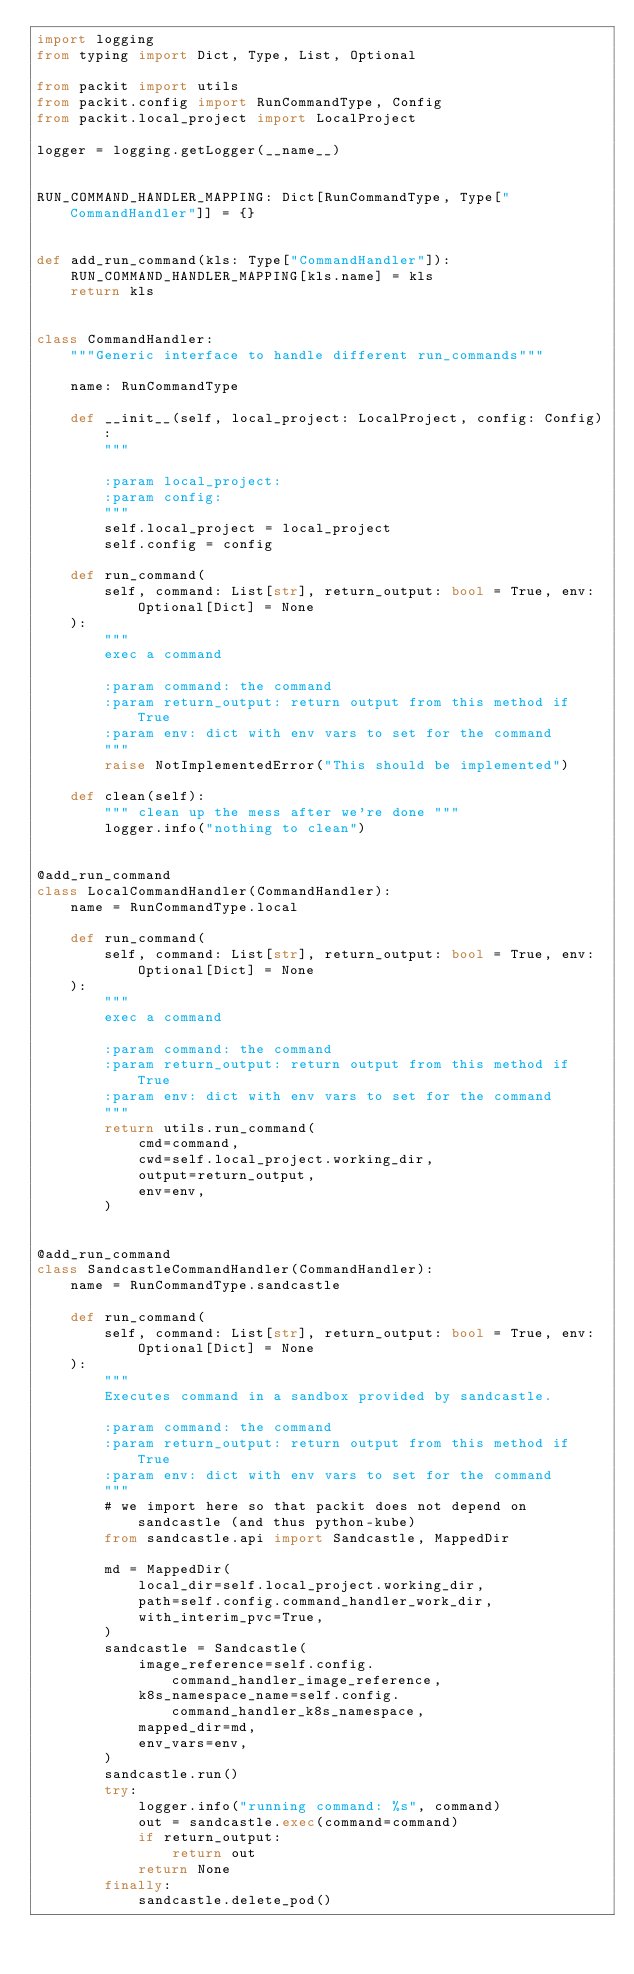<code> <loc_0><loc_0><loc_500><loc_500><_Python_>import logging
from typing import Dict, Type, List, Optional

from packit import utils
from packit.config import RunCommandType, Config
from packit.local_project import LocalProject

logger = logging.getLogger(__name__)


RUN_COMMAND_HANDLER_MAPPING: Dict[RunCommandType, Type["CommandHandler"]] = {}


def add_run_command(kls: Type["CommandHandler"]):
    RUN_COMMAND_HANDLER_MAPPING[kls.name] = kls
    return kls


class CommandHandler:
    """Generic interface to handle different run_commands"""

    name: RunCommandType

    def __init__(self, local_project: LocalProject, config: Config):
        """

        :param local_project:
        :param config:
        """
        self.local_project = local_project
        self.config = config

    def run_command(
        self, command: List[str], return_output: bool = True, env: Optional[Dict] = None
    ):
        """
        exec a command

        :param command: the command
        :param return_output: return output from this method if True
        :param env: dict with env vars to set for the command
        """
        raise NotImplementedError("This should be implemented")

    def clean(self):
        """ clean up the mess after we're done """
        logger.info("nothing to clean")


@add_run_command
class LocalCommandHandler(CommandHandler):
    name = RunCommandType.local

    def run_command(
        self, command: List[str], return_output: bool = True, env: Optional[Dict] = None
    ):
        """
        exec a command

        :param command: the command
        :param return_output: return output from this method if True
        :param env: dict with env vars to set for the command
        """
        return utils.run_command(
            cmd=command,
            cwd=self.local_project.working_dir,
            output=return_output,
            env=env,
        )


@add_run_command
class SandcastleCommandHandler(CommandHandler):
    name = RunCommandType.sandcastle

    def run_command(
        self, command: List[str], return_output: bool = True, env: Optional[Dict] = None
    ):
        """
        Executes command in a sandbox provided by sandcastle.

        :param command: the command
        :param return_output: return output from this method if True
        :param env: dict with env vars to set for the command
        """
        # we import here so that packit does not depend on sandcastle (and thus python-kube)
        from sandcastle.api import Sandcastle, MappedDir

        md = MappedDir(
            local_dir=self.local_project.working_dir,
            path=self.config.command_handler_work_dir,
            with_interim_pvc=True,
        )
        sandcastle = Sandcastle(
            image_reference=self.config.command_handler_image_reference,
            k8s_namespace_name=self.config.command_handler_k8s_namespace,
            mapped_dir=md,
            env_vars=env,
        )
        sandcastle.run()
        try:
            logger.info("running command: %s", command)
            out = sandcastle.exec(command=command)
            if return_output:
                return out
            return None
        finally:
            sandcastle.delete_pod()
</code> 